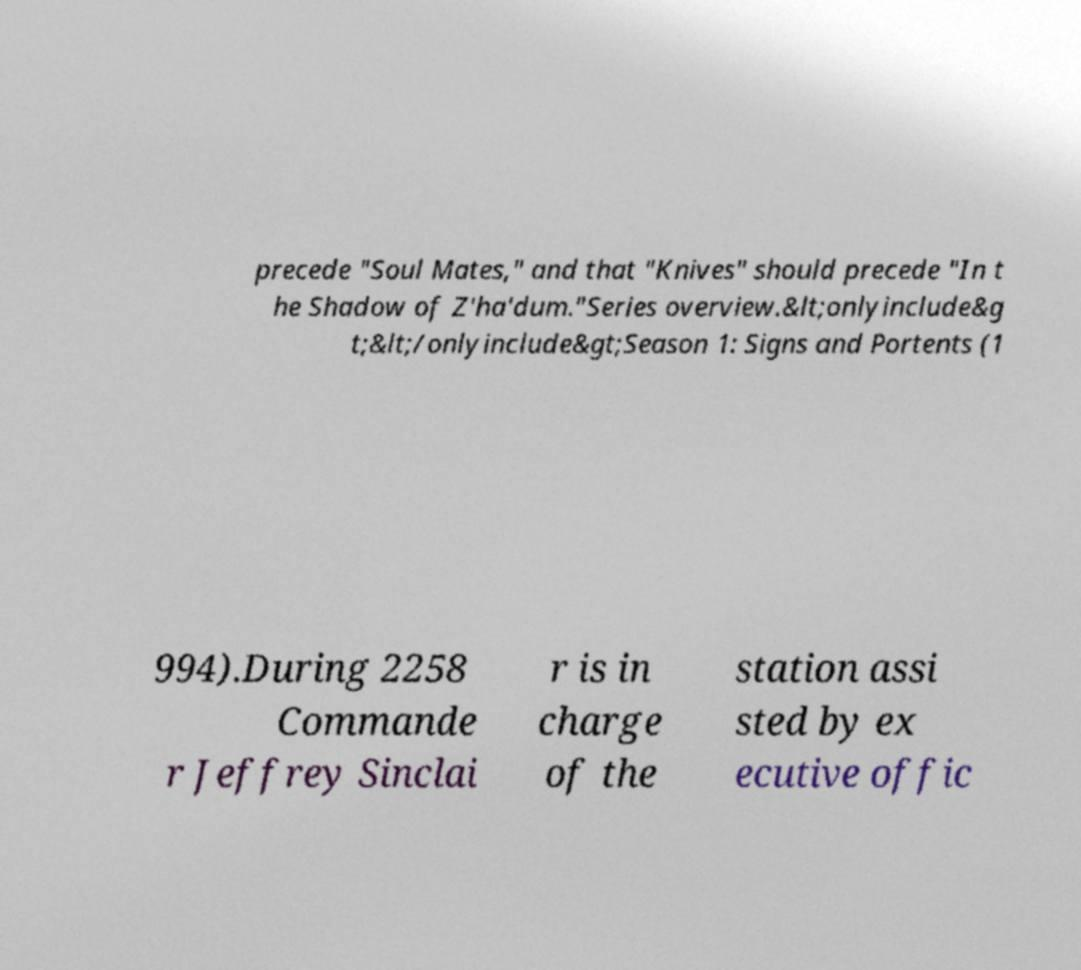There's text embedded in this image that I need extracted. Can you transcribe it verbatim? precede "Soul Mates," and that "Knives" should precede "In t he Shadow of Z'ha'dum."Series overview.&lt;onlyinclude&g t;&lt;/onlyinclude&gt;Season 1: Signs and Portents (1 994).During 2258 Commande r Jeffrey Sinclai r is in charge of the station assi sted by ex ecutive offic 